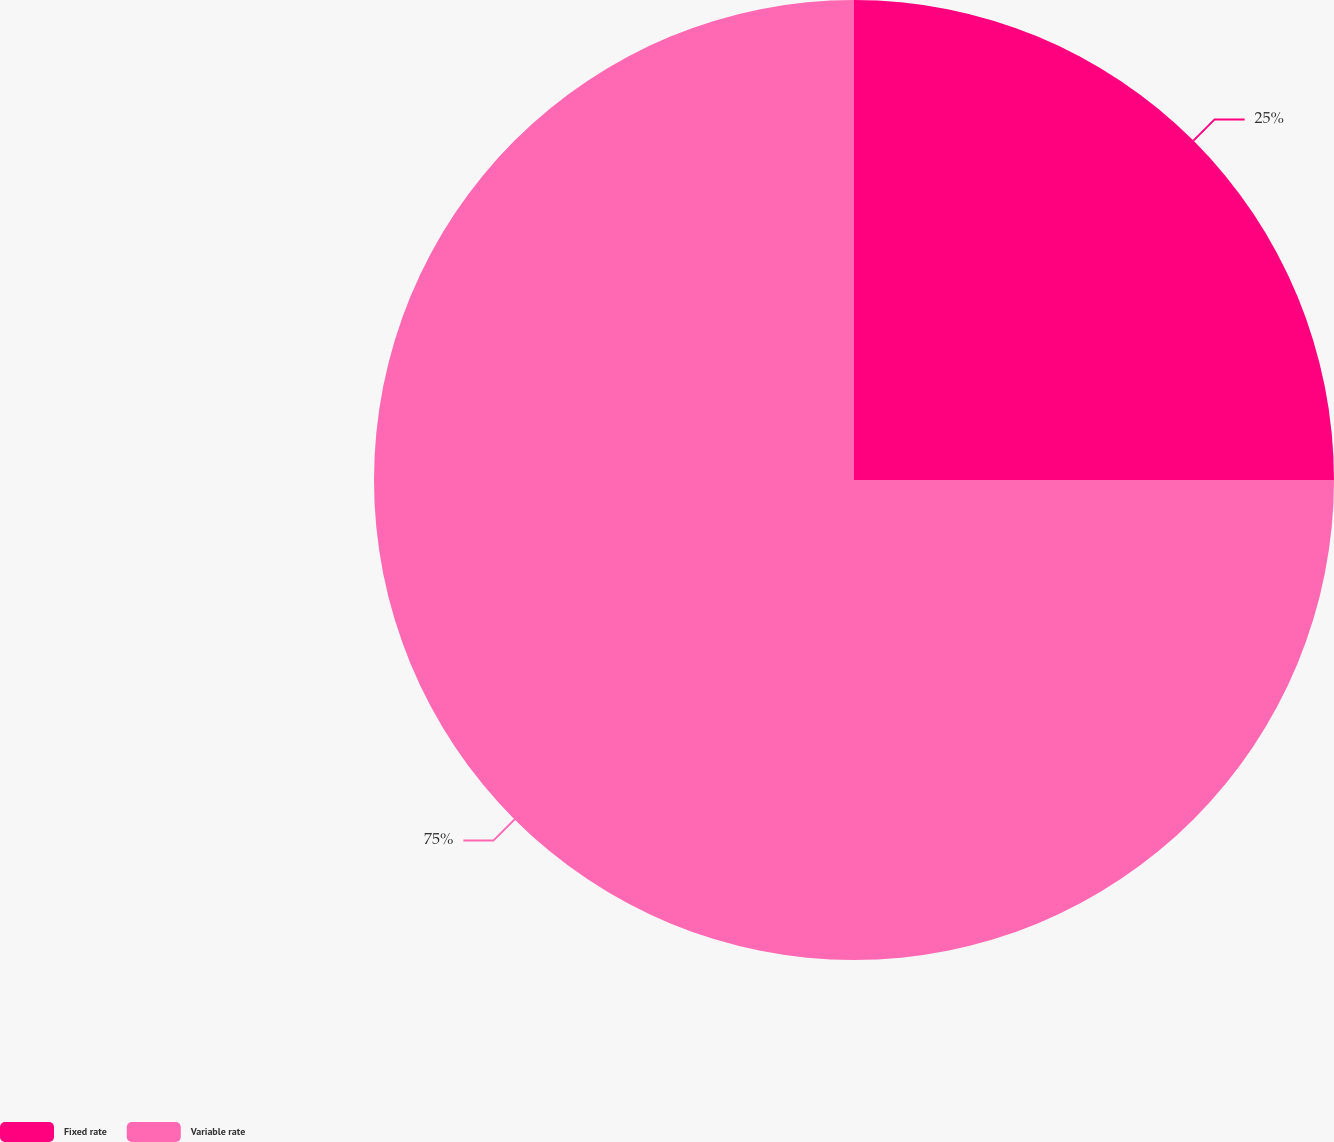<chart> <loc_0><loc_0><loc_500><loc_500><pie_chart><fcel>Fixed rate<fcel>Variable rate<nl><fcel>25.0%<fcel>75.0%<nl></chart> 